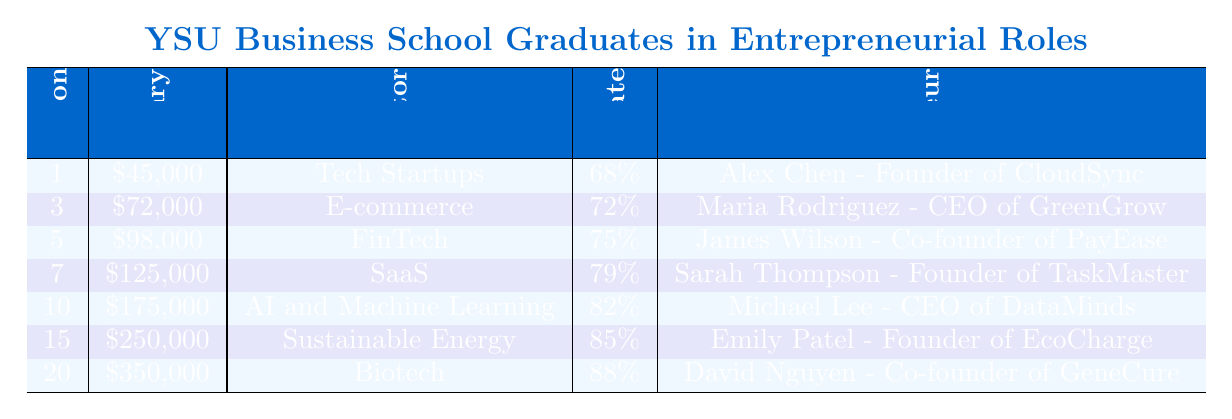What is the average annual salary of YSU Business School graduates after 5 years? From the table, the average annual salary after 5 years is listed as $98,000.
Answer: $98,000 Which sector had the highest average annual salary 20 years after graduation? According to the table, the sector with the highest average annual salary after 20 years is Biotech, with a salary of $350,000.
Answer: Biotech Is the YSU Alumni Success Rate after 10 years higher than that after 3 years? The success rate after 10 years is 82%, and after 3 years, it is 72%. Since 82% is greater than 72%, the statement is true.
Answer: Yes What is the total average salary progression from 1 year to 20 years after graduation? To find the total progression, sum the salaries: $45,000 + $72,000 + $98,000 + $125,000 + $175,000 + $250,000 + $350,000 = $1,115,000.
Answer: $1,115,000 Does the average annual salary increase consistently with each additional year after graduation? By evaluating the salaries for each year after graduation, it can be seen that each subsequent year has a higher salary than the previous one, indicating consistent growth.
Answer: Yes Which notable YSU entrepreneur is linked to the Sustainable Energy sector? The table indicates that Emily Patel is the notable entrepreneur associated with the Sustainable Energy sector.
Answer: Emily Patel What is the percentage increase in average annual salary from year 3 to year 5? The average salary in year 3 is $72,000 and in year 5 it is $98,000. The increase is $98,000 - $72,000 = $26,000. The percentage increase is ($26,000 / $72,000) * 100 = approximately 36.11%.
Answer: Approximately 36.11% How many notable entrepreneurs are listed in the table? There are a total of 7 notable entrepreneurs listed across the rows of the table.
Answer: 7 What is the YSU Alumni Success Rate after 15 years? The table specifies that the YSU Alumni Success Rate after 15 years is 85%.
Answer: 85% Identify the average salary progression from years 7 to 10. The average salary after 7 years is $125,000 and after 10 years is $175,000. The increase is $175,000 - $125,000 = $50,000, indicating significant growth.
Answer: $50,000 